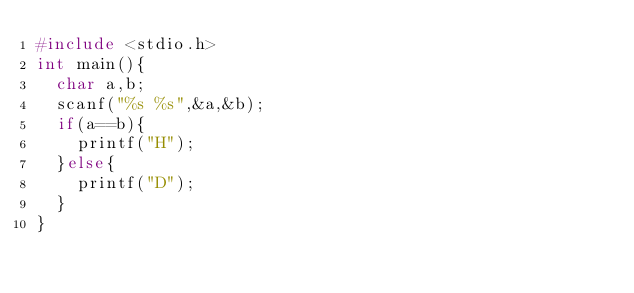<code> <loc_0><loc_0><loc_500><loc_500><_C_>#include <stdio.h>
int main(){		
	char a,b;
	scanf("%s %s",&a,&b);
	if(a==b){
		printf("H");
	}else{
		printf("D");
	}
}</code> 